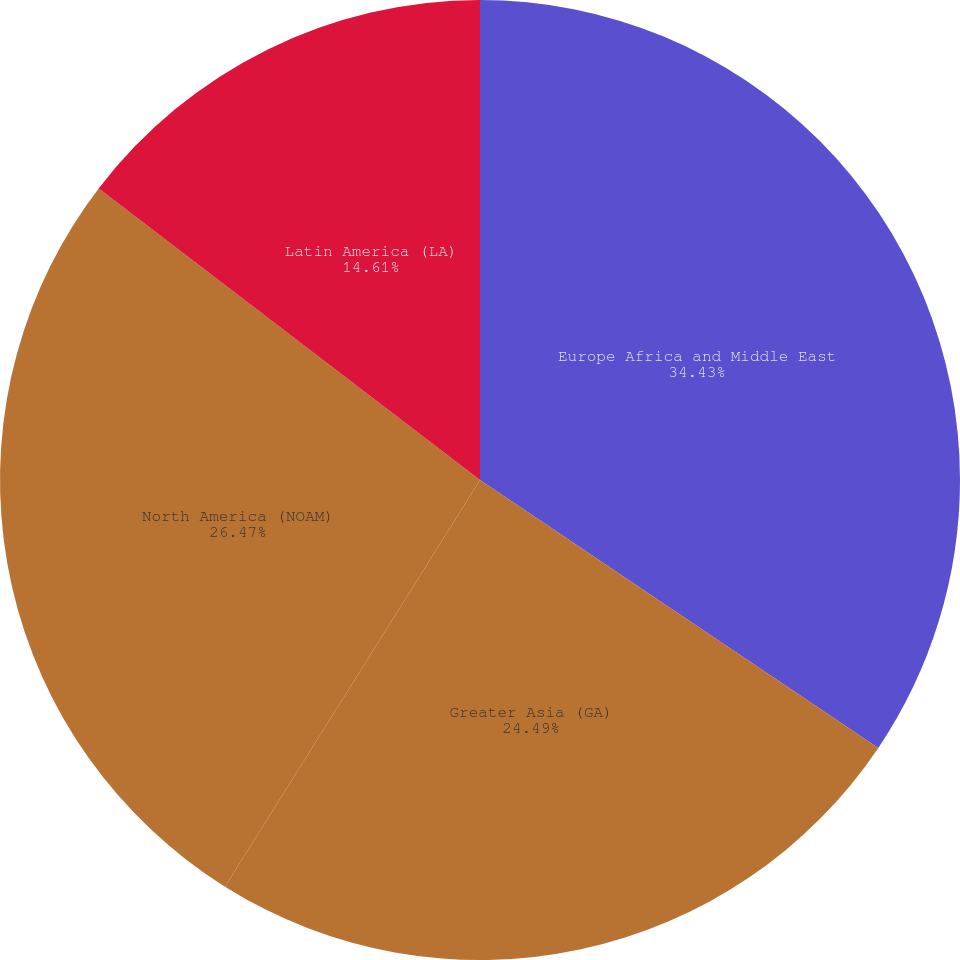<chart> <loc_0><loc_0><loc_500><loc_500><pie_chart><fcel>Europe Africa and Middle East<fcel>Greater Asia (GA)<fcel>North America (NOAM)<fcel>Latin America (LA)<nl><fcel>34.42%<fcel>24.49%<fcel>26.47%<fcel>14.61%<nl></chart> 